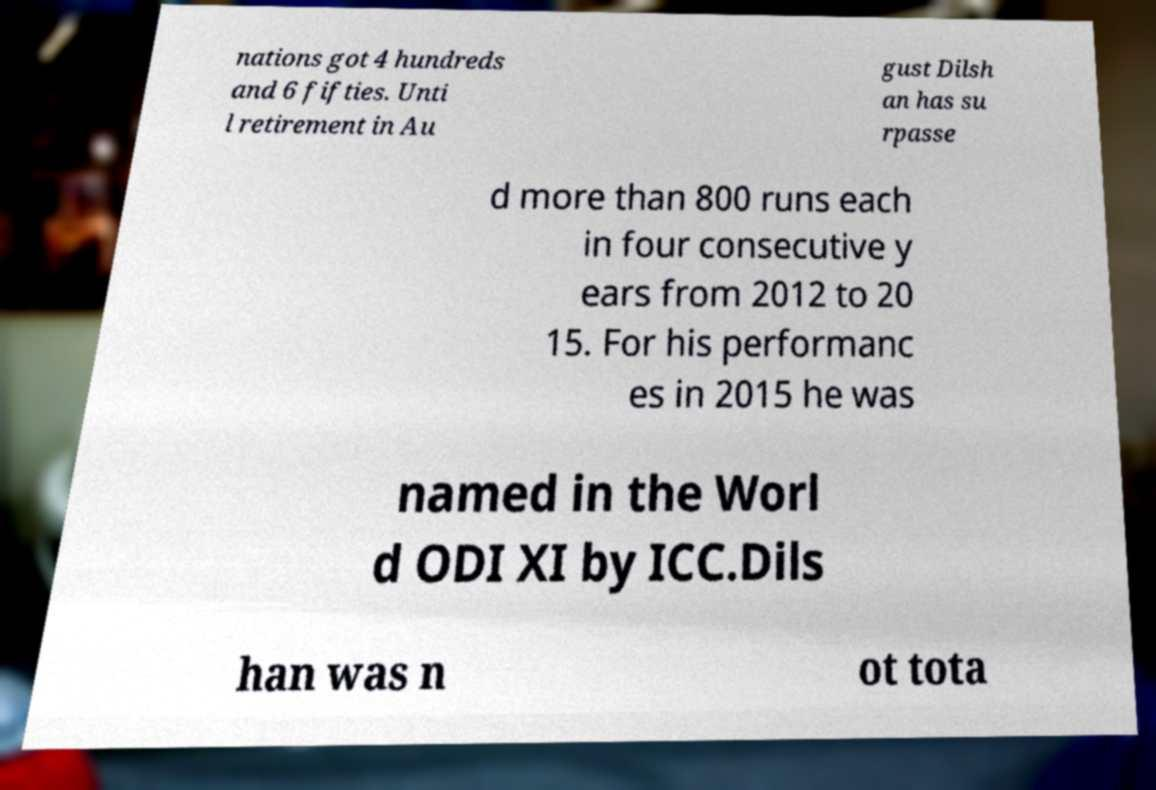I need the written content from this picture converted into text. Can you do that? nations got 4 hundreds and 6 fifties. Unti l retirement in Au gust Dilsh an has su rpasse d more than 800 runs each in four consecutive y ears from 2012 to 20 15. For his performanc es in 2015 he was named in the Worl d ODI XI by ICC.Dils han was n ot tota 